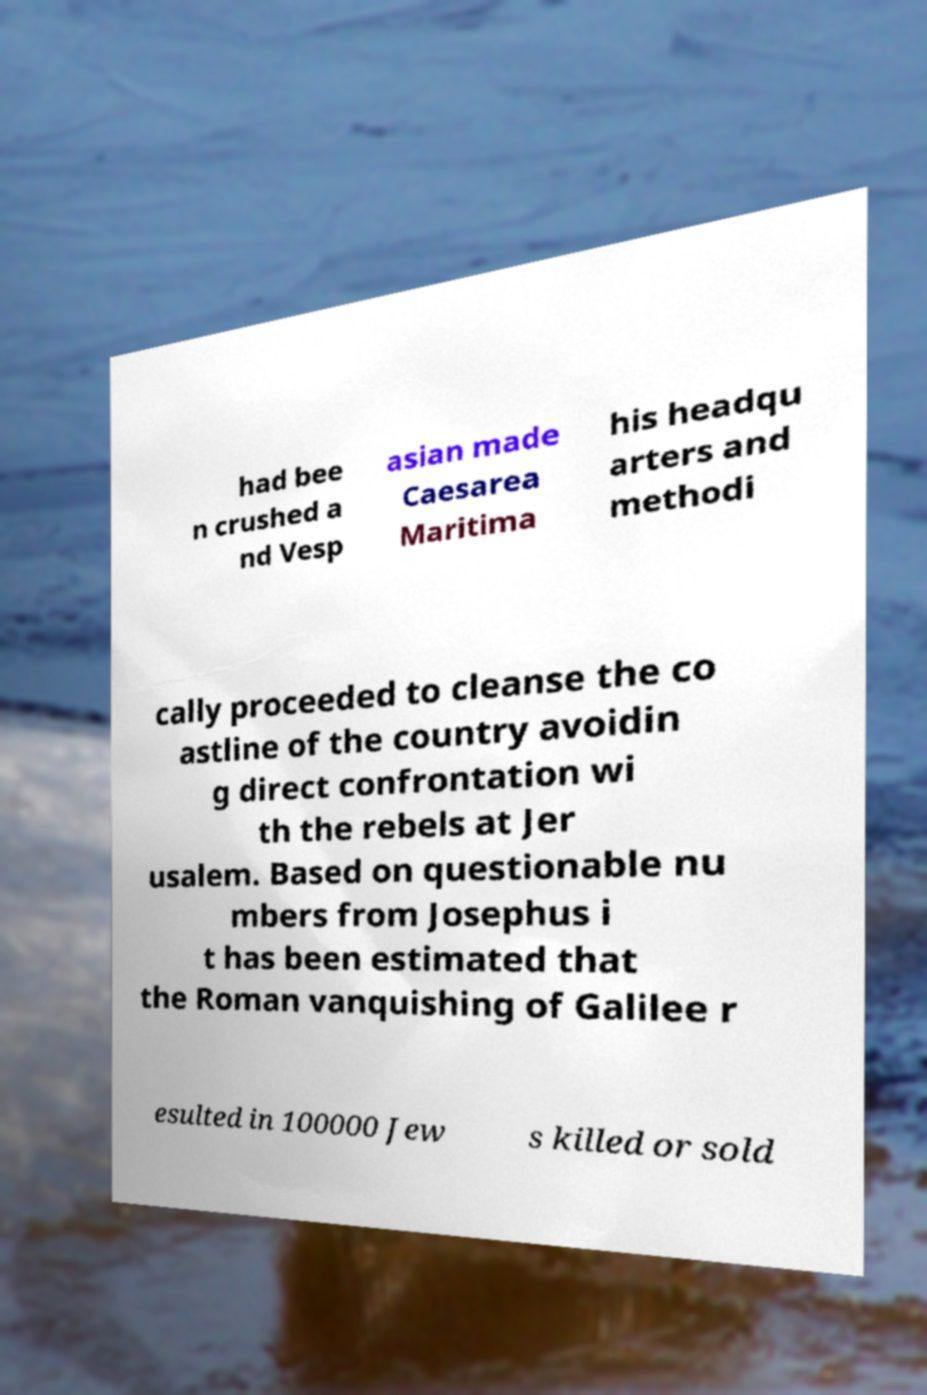What messages or text are displayed in this image? I need them in a readable, typed format. had bee n crushed a nd Vesp asian made Caesarea Maritima his headqu arters and methodi cally proceeded to cleanse the co astline of the country avoidin g direct confrontation wi th the rebels at Jer usalem. Based on questionable nu mbers from Josephus i t has been estimated that the Roman vanquishing of Galilee r esulted in 100000 Jew s killed or sold 